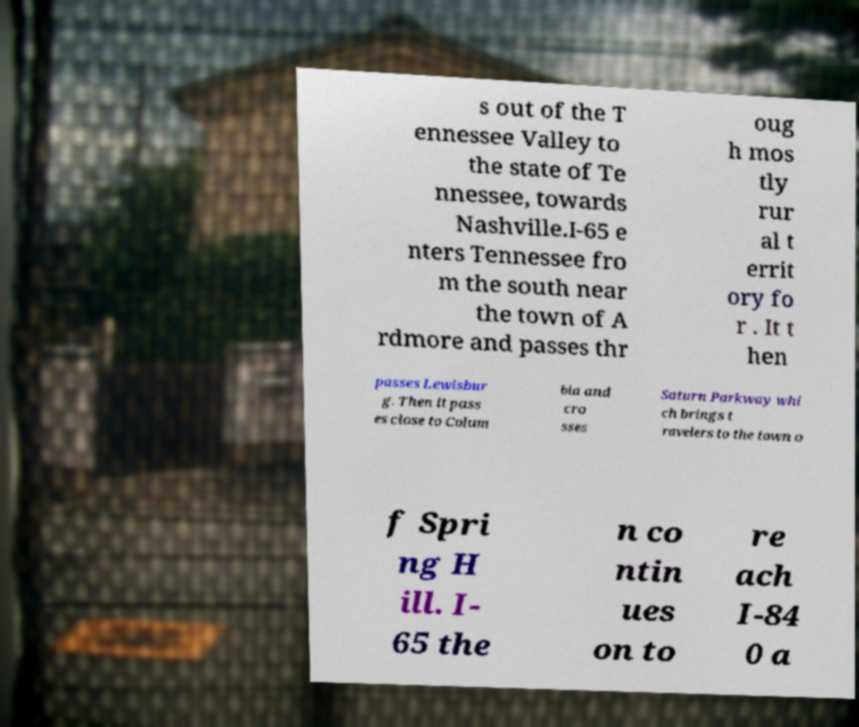For documentation purposes, I need the text within this image transcribed. Could you provide that? s out of the T ennessee Valley to the state of Te nnessee, towards Nashville.I-65 e nters Tennessee fro m the south near the town of A rdmore and passes thr oug h mos tly rur al t errit ory fo r . It t hen passes Lewisbur g. Then it pass es close to Colum bia and cro sses Saturn Parkway whi ch brings t ravelers to the town o f Spri ng H ill. I- 65 the n co ntin ues on to re ach I-84 0 a 